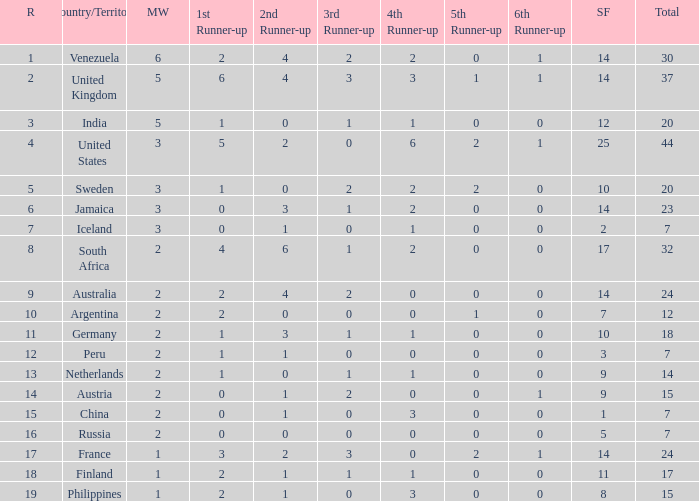What is the overall ranking of venezuela? 30.0. 